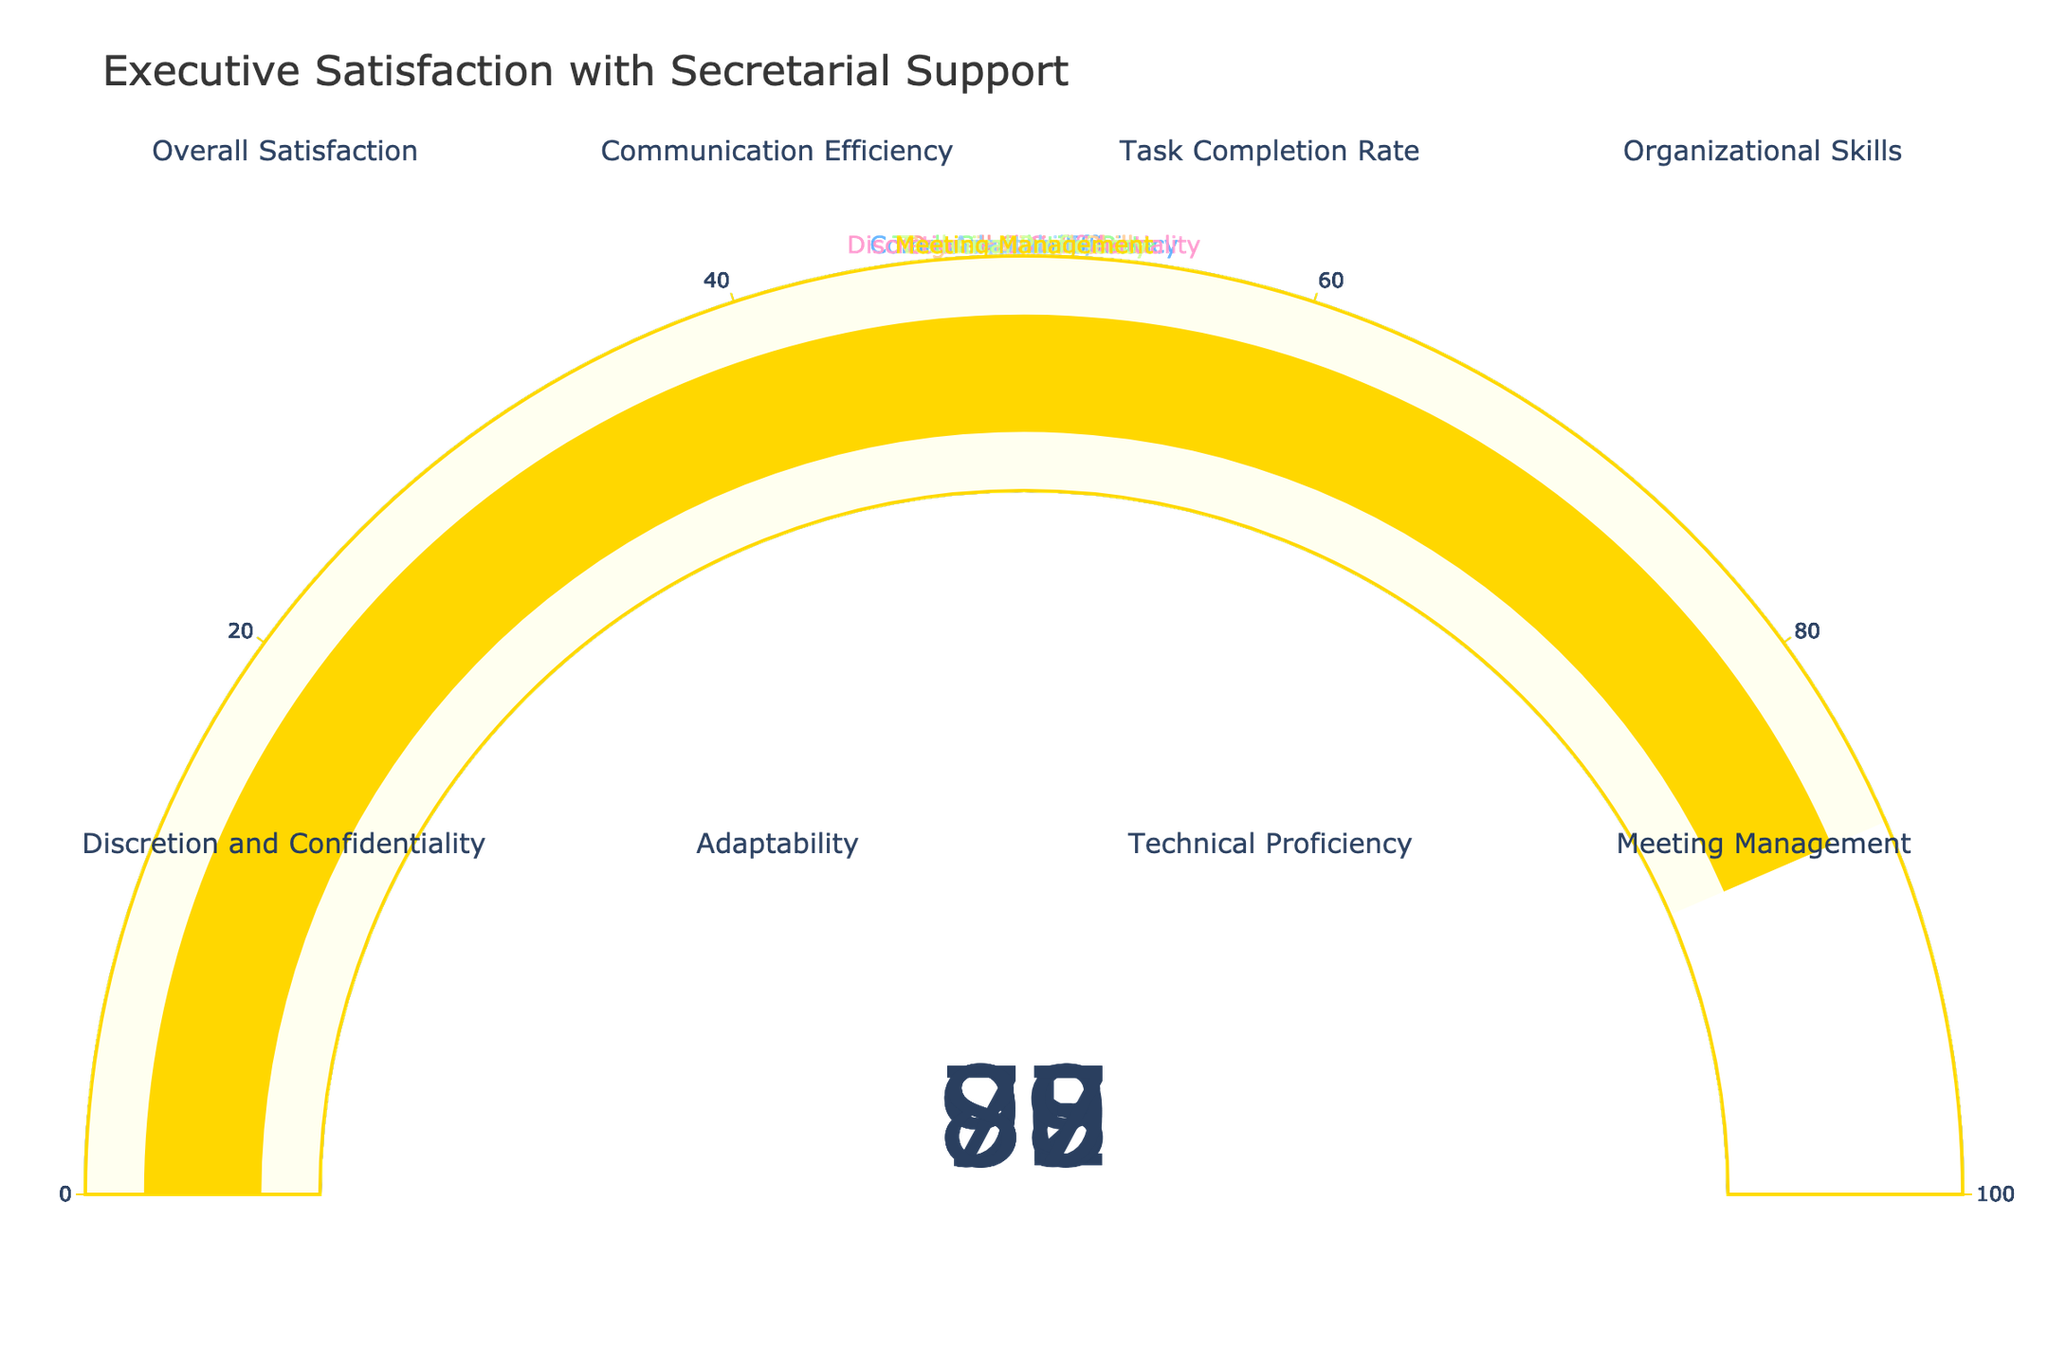What is the overall satisfaction rate of executives with their current secretarial support? The "Overall Satisfaction" gauge shows a value of 85.
Answer: 85 Which metric has the highest satisfaction rate? The metric with the highest value is "Discretion and Confidentiality" with a satisfaction rate of 95.
Answer: Discretion and Confidentiality How many metrics have a satisfaction rate of 90 or above? The gauges for "Communication Efficiency" (92), "Organizational Skills" (90), "Discretion and Confidentiality" (95) and "Task Completion Rate" (88) show values of 90 or above. The count is 3.
Answer: 3 What’s the difference in satisfaction rate between "Technical Proficiency" and "Communication Efficiency"? Subtract the value of "Technical Proficiency" (79) from "Communication Efficiency" (92): 92 - 79 = 13.
Answer: 13 Which metric has the lowest satisfaction rate, and what is its value? The gauge for "Technical Proficiency" shows the lowest value of 79.
Answer: Technical Proficiency, 79 Is the satisfaction in "Meeting Management" higher or lower than the "Task Completion Rate"? The value for "Task Completion Rate" is 88, and for "Meeting Management" is 87. Thus, "Meeting Management" is lower.
Answer: Lower What is the average satisfaction rate across all metrics? The sum of all values is: 85 + 92 + 88 + 90 + 95 + 83 + 79 + 87 = 699. There are 8 metrics, so the average is 699 / 8 = 87.375.
Answer: 87.375 Which values are above the overall satisfaction rate? The overall satisfaction rate is 85. "Communication Efficiency" (92), "Task Completion Rate" (88), "Organizational Skills" (90), "Discretion and Confidentiality" (95), and "Meeting Management" (87) are all above this rate.
Answer: Communication Efficiency, Task Completion Rate, Organizational Skills, Discretion and Confidentiality, Meeting Management How much greater is the satisfaction rate for "Discretion and Confidentiality" compared to "Adaptability"? Subtract the value of "Adaptability" (83) from "Discretion and Confidentiality" (95): 95 - 83 = 12.
Answer: 12 